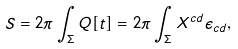<formula> <loc_0><loc_0><loc_500><loc_500>S = 2 \pi \int _ { \Sigma } Q [ t ] = 2 \pi \int _ { \Sigma } X ^ { c d } \epsilon _ { c d } ,</formula> 